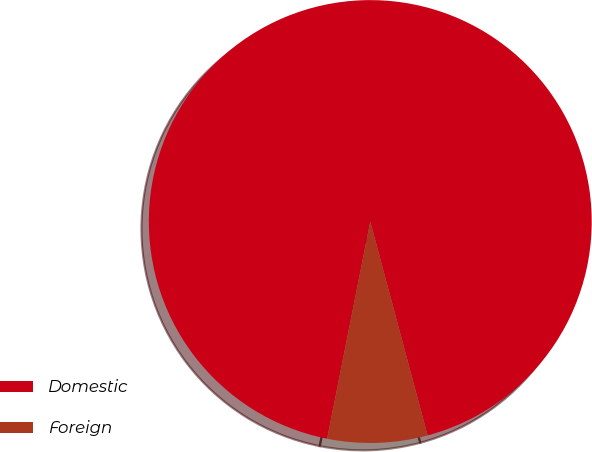<chart> <loc_0><loc_0><loc_500><loc_500><pie_chart><fcel>Domestic<fcel>Foreign<nl><fcel>92.71%<fcel>7.29%<nl></chart> 